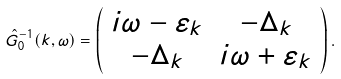<formula> <loc_0><loc_0><loc_500><loc_500>\hat { G } ^ { - 1 } _ { 0 } ( { k } , \omega ) = \left ( \begin{array} { c c } i \omega - \varepsilon _ { k } & - \Delta _ { k } \\ - \Delta _ { k } & i \omega + \varepsilon _ { k } \end{array} \right ) .</formula> 